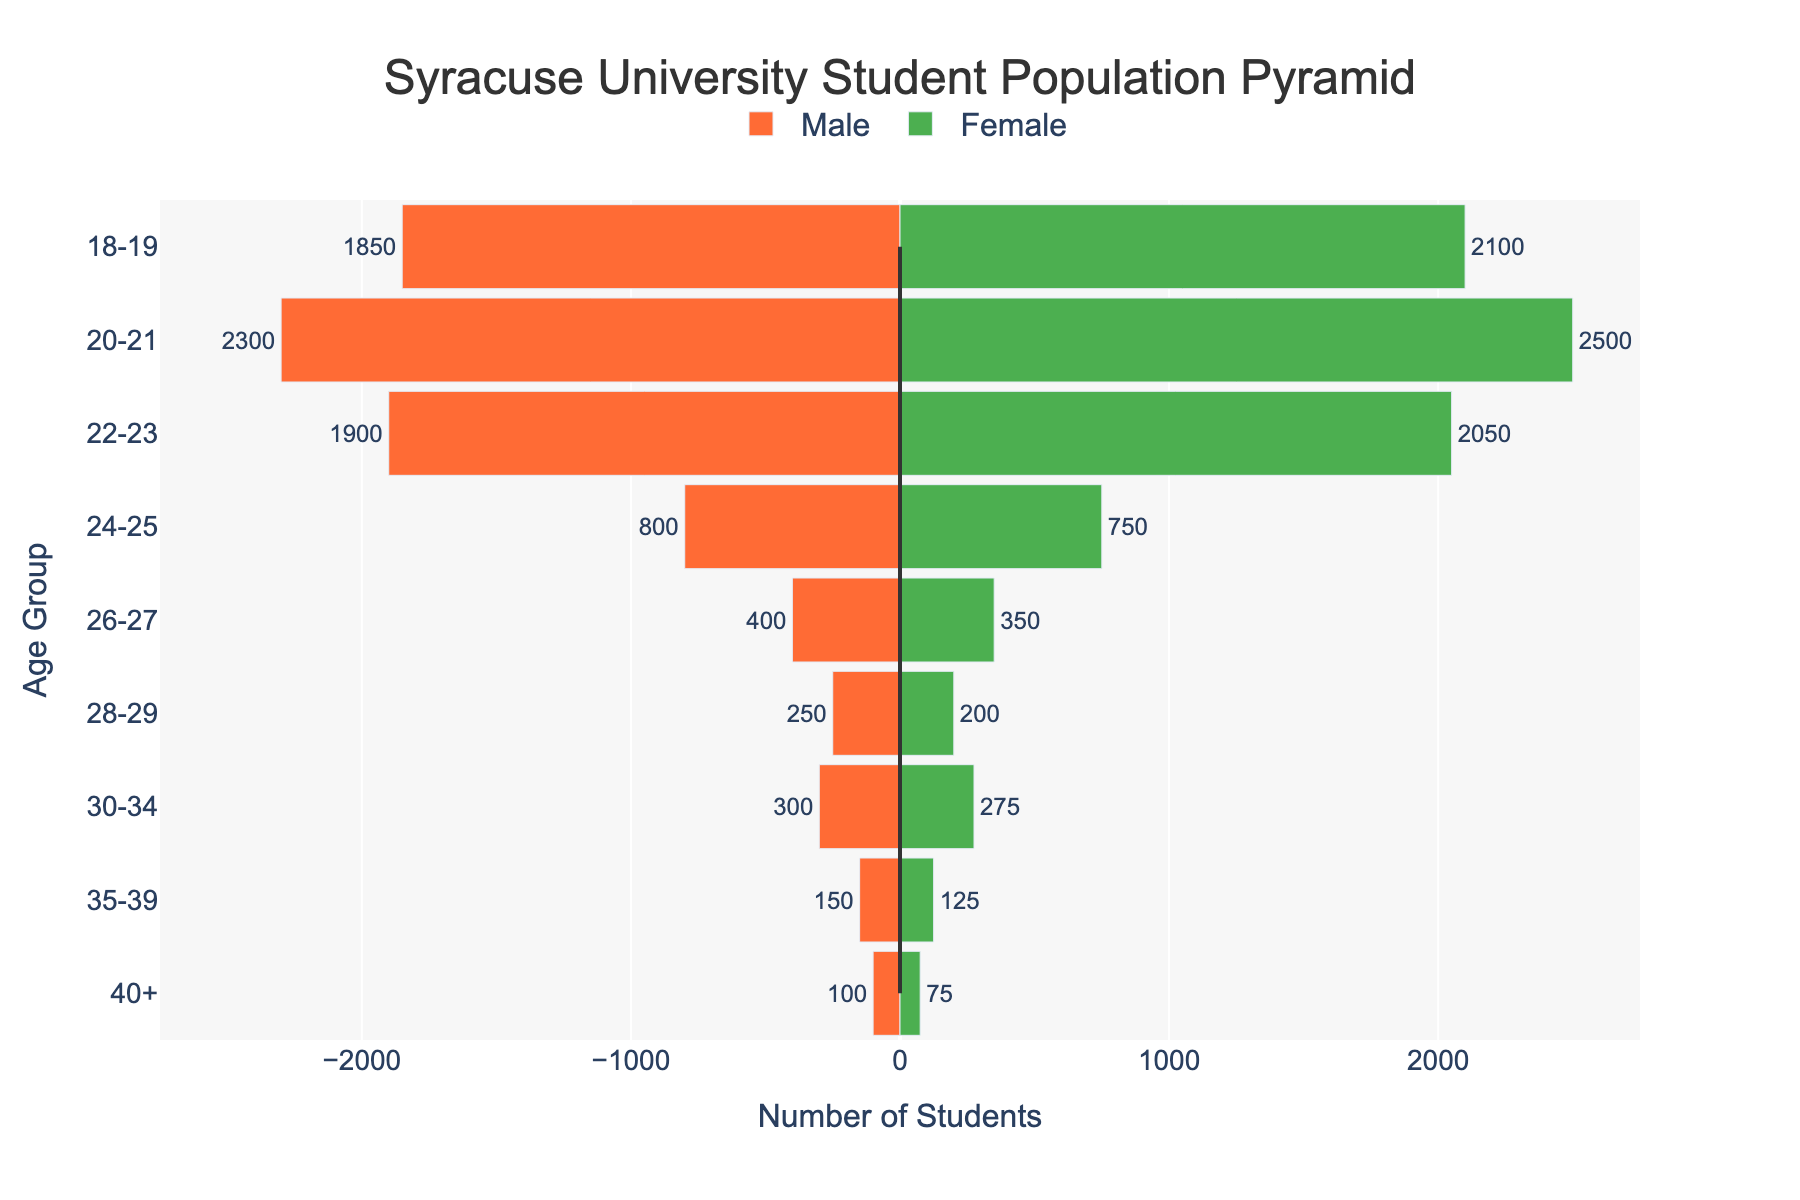What's the title of the chart? The title is located at the top of the chart. It usually gives a summary of what the chart represents.
Answer: "Syracuse University Student Population Pyramid" What age group has the highest number of male students? The age group with the longest bar on the left side of the chart represents the highest number of male students.
Answer: 20-21 Which age group has the smallest number of female students? The age group with the shortest bar on the right side of the chart represents the smallest number of female students.
Answer: 40+ How many female students are in the age group 22-23? Look at the bar corresponding to the age 22-23 on the right side of the chart and read its value.
Answer: 2050 What's the total number of male students in the age groups 18-19 and 20-21? Sum the numbers of male students for age groups 18-19 and 20-21. 1850 + 2300 = 4150
Answer: 4150 Which gender has more students in the age group 24-25? Compare the lengths of the bars for males and females in the age group 24-25. The higher value determines which gender has more students.
Answer: Male What is the difference in the number of students between males and females in the age group 30-34? Find the values for males and females in the age group 30-34 and subtract the smaller number from the larger one.
Answer: 25 Which age group has the most balanced gender ratio? Compare the lengths of the bars for both genders across all age groups, finding the smallest difference in lengths.
Answer: 24-25 What overall trend do you observe in the number of students as age increases? Look at the bars from youngest age group to the oldest age group and identify the pattern.
Answer: The number of students decreases as age increases 